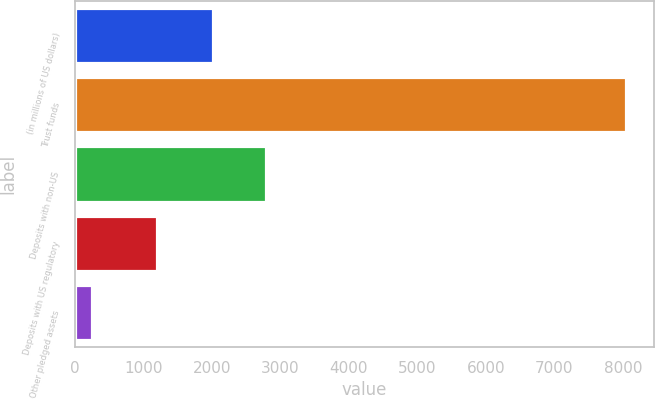<chart> <loc_0><loc_0><loc_500><loc_500><bar_chart><fcel>(in millions of US dollars)<fcel>Trust funds<fcel>Deposits with non-US<fcel>Deposits with US regulatory<fcel>Other pledged assets<nl><fcel>2009<fcel>8047<fcel>2789.2<fcel>1199<fcel>245<nl></chart> 